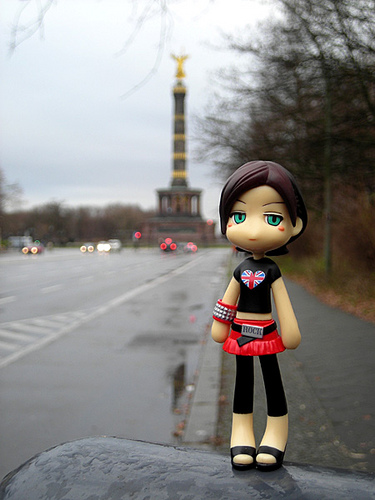<image>
Can you confirm if the heart is to the right of the street? Yes. From this viewpoint, the heart is positioned to the right side relative to the street. 